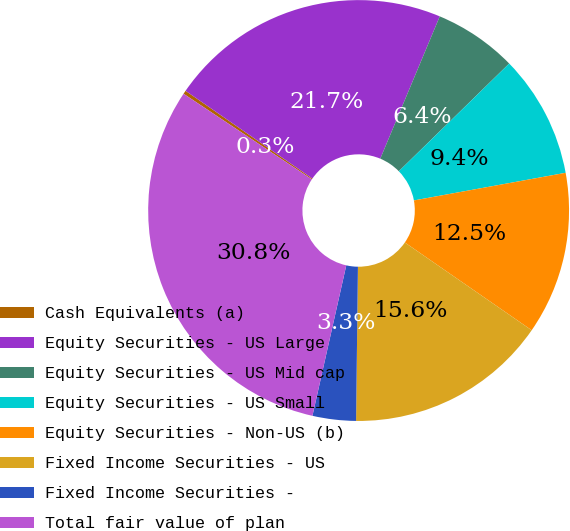Convert chart. <chart><loc_0><loc_0><loc_500><loc_500><pie_chart><fcel>Cash Equivalents (a)<fcel>Equity Securities - US Large<fcel>Equity Securities - US Mid cap<fcel>Equity Securities - US Small<fcel>Equity Securities - Non-US (b)<fcel>Fixed Income Securities - US<fcel>Fixed Income Securities -<fcel>Total fair value of plan<nl><fcel>0.27%<fcel>21.67%<fcel>6.39%<fcel>9.44%<fcel>12.5%<fcel>15.56%<fcel>3.33%<fcel>30.84%<nl></chart> 